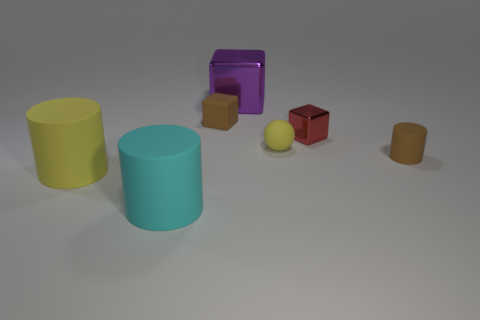Are there the same number of brown objects that are behind the tiny red metal thing and red things?
Make the answer very short. Yes. What number of cylinders are either large cyan objects or metal things?
Provide a short and direct response. 1. Is the tiny matte cylinder the same color as the small matte block?
Provide a short and direct response. Yes. Is the number of tiny red shiny things in front of the sphere the same as the number of purple things right of the large purple metallic block?
Give a very brief answer. Yes. The large metallic block has what color?
Your response must be concise. Purple. How many things are either yellow rubber objects that are left of the big purple shiny object or tiny green matte blocks?
Provide a short and direct response. 1. There is a rubber cylinder right of the big purple block; is its size the same as the yellow object that is in front of the tiny rubber cylinder?
Ensure brevity in your answer.  No. What number of objects are tiny things that are behind the small metallic thing or rubber cylinders that are to the right of the cyan cylinder?
Your answer should be very brief. 2. Is the tiny cylinder made of the same material as the big thing behind the tiny cylinder?
Provide a short and direct response. No. What is the shape of the tiny object that is to the left of the small red metallic block and in front of the red metallic cube?
Provide a succinct answer. Sphere. 